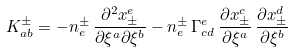Convert formula to latex. <formula><loc_0><loc_0><loc_500><loc_500>K _ { a b } ^ { \pm } = - n _ { e } ^ { \pm } \, \frac { \partial ^ { 2 } x _ { \pm } ^ { e } } { \partial \xi ^ { a } \partial \xi ^ { b } } - n _ { e } ^ { \pm } \, \Gamma _ { c d } ^ { e } \, \frac { \partial x _ { \pm } ^ { c } } { \partial \xi ^ { a } } \, \frac { \partial x _ { \pm } ^ { d } } { \partial \xi ^ { b } }</formula> 